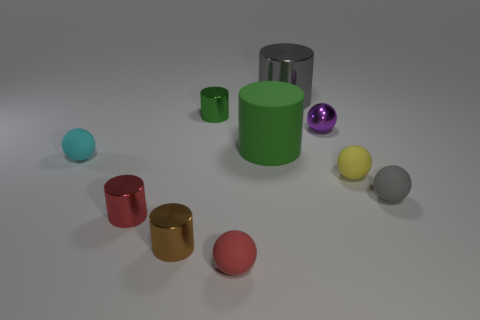Subtract all brown cylinders. How many cylinders are left? 4 Subtract all tiny brown shiny cylinders. How many cylinders are left? 4 Subtract all blue cylinders. Subtract all yellow cubes. How many cylinders are left? 5 Subtract all tiny purple shiny spheres. Subtract all small objects. How many objects are left? 1 Add 8 small yellow things. How many small yellow things are left? 9 Add 6 big shiny cylinders. How many big shiny cylinders exist? 7 Subtract 0 green cubes. How many objects are left? 10 